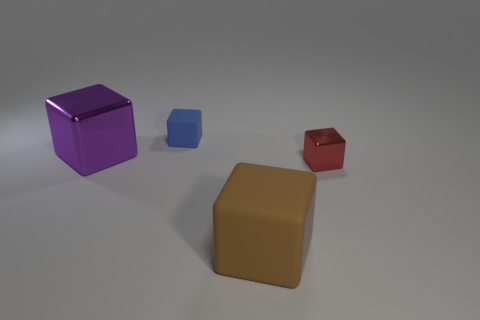Subtract all big metallic blocks. How many blocks are left? 3 Add 3 big blue metallic things. How many objects exist? 7 Subtract all red cubes. How many cubes are left? 3 Subtract all brown cubes. Subtract all gray spheres. How many cubes are left? 3 Add 4 blue matte blocks. How many blue matte blocks are left? 5 Add 1 red metallic cubes. How many red metallic cubes exist? 2 Subtract 0 gray cubes. How many objects are left? 4 Subtract all small red cubes. Subtract all blue cubes. How many objects are left? 2 